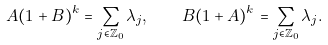Convert formula to latex. <formula><loc_0><loc_0><loc_500><loc_500>A ( 1 + B ) ^ { k } = \sum _ { j \in \mathbb { Z } _ { 0 } } \lambda _ { j } , \quad B ( 1 + A ) ^ { k } = \sum _ { j \in \mathbb { Z } _ { 0 } } \lambda _ { j } .</formula> 